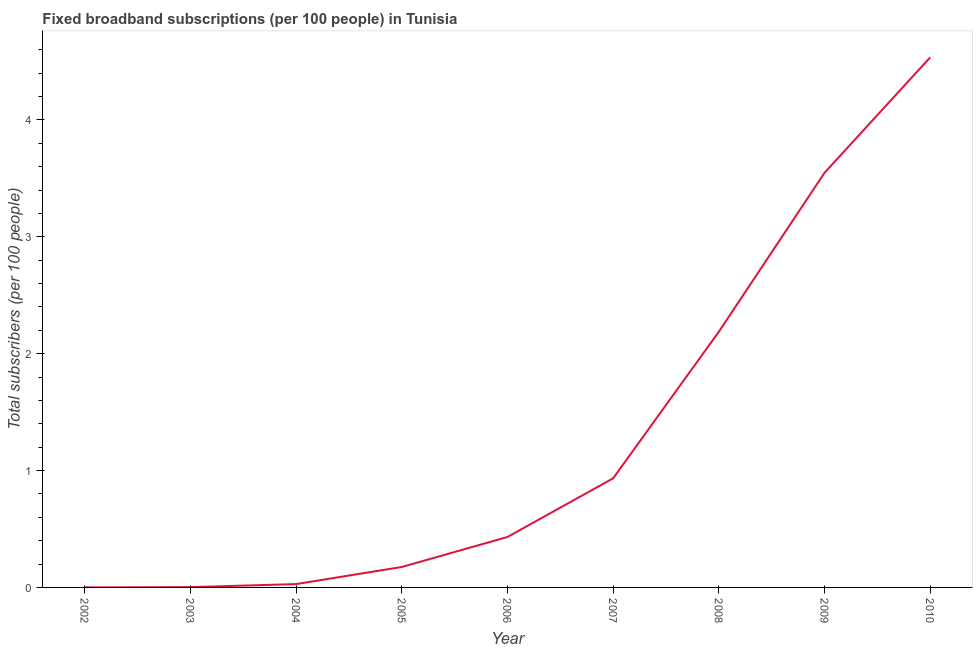What is the total number of fixed broadband subscriptions in 2009?
Offer a very short reply. 3.55. Across all years, what is the maximum total number of fixed broadband subscriptions?
Make the answer very short. 4.54. Across all years, what is the minimum total number of fixed broadband subscriptions?
Your answer should be very brief. 0. What is the sum of the total number of fixed broadband subscriptions?
Offer a terse response. 11.84. What is the difference between the total number of fixed broadband subscriptions in 2003 and 2009?
Your answer should be compact. -3.54. What is the average total number of fixed broadband subscriptions per year?
Make the answer very short. 1.32. What is the median total number of fixed broadband subscriptions?
Offer a very short reply. 0.43. Do a majority of the years between 2005 and 2002 (inclusive) have total number of fixed broadband subscriptions greater than 3.2 ?
Provide a succinct answer. Yes. What is the ratio of the total number of fixed broadband subscriptions in 2004 to that in 2010?
Keep it short and to the point. 0.01. Is the total number of fixed broadband subscriptions in 2002 less than that in 2005?
Keep it short and to the point. Yes. What is the difference between the highest and the second highest total number of fixed broadband subscriptions?
Ensure brevity in your answer.  0.99. What is the difference between the highest and the lowest total number of fixed broadband subscriptions?
Ensure brevity in your answer.  4.54. What is the difference between two consecutive major ticks on the Y-axis?
Provide a short and direct response. 1. Are the values on the major ticks of Y-axis written in scientific E-notation?
Provide a short and direct response. No. Does the graph contain grids?
Make the answer very short. No. What is the title of the graph?
Give a very brief answer. Fixed broadband subscriptions (per 100 people) in Tunisia. What is the label or title of the Y-axis?
Provide a short and direct response. Total subscribers (per 100 people). What is the Total subscribers (per 100 people) in 2002?
Give a very brief answer. 0. What is the Total subscribers (per 100 people) in 2003?
Provide a short and direct response. 0. What is the Total subscribers (per 100 people) in 2004?
Ensure brevity in your answer.  0.03. What is the Total subscribers (per 100 people) of 2005?
Make the answer very short. 0.17. What is the Total subscribers (per 100 people) of 2006?
Give a very brief answer. 0.43. What is the Total subscribers (per 100 people) of 2007?
Provide a succinct answer. 0.93. What is the Total subscribers (per 100 people) of 2008?
Give a very brief answer. 2.19. What is the Total subscribers (per 100 people) in 2009?
Your answer should be very brief. 3.55. What is the Total subscribers (per 100 people) in 2010?
Ensure brevity in your answer.  4.54. What is the difference between the Total subscribers (per 100 people) in 2002 and 2003?
Your answer should be compact. -0. What is the difference between the Total subscribers (per 100 people) in 2002 and 2004?
Your response must be concise. -0.03. What is the difference between the Total subscribers (per 100 people) in 2002 and 2005?
Offer a very short reply. -0.17. What is the difference between the Total subscribers (per 100 people) in 2002 and 2006?
Your response must be concise. -0.43. What is the difference between the Total subscribers (per 100 people) in 2002 and 2007?
Offer a terse response. -0.93. What is the difference between the Total subscribers (per 100 people) in 2002 and 2008?
Ensure brevity in your answer.  -2.19. What is the difference between the Total subscribers (per 100 people) in 2002 and 2009?
Make the answer very short. -3.55. What is the difference between the Total subscribers (per 100 people) in 2002 and 2010?
Ensure brevity in your answer.  -4.54. What is the difference between the Total subscribers (per 100 people) in 2003 and 2004?
Your response must be concise. -0.03. What is the difference between the Total subscribers (per 100 people) in 2003 and 2005?
Keep it short and to the point. -0.17. What is the difference between the Total subscribers (per 100 people) in 2003 and 2006?
Provide a short and direct response. -0.43. What is the difference between the Total subscribers (per 100 people) in 2003 and 2007?
Offer a very short reply. -0.93. What is the difference between the Total subscribers (per 100 people) in 2003 and 2008?
Provide a short and direct response. -2.19. What is the difference between the Total subscribers (per 100 people) in 2003 and 2009?
Provide a short and direct response. -3.54. What is the difference between the Total subscribers (per 100 people) in 2003 and 2010?
Provide a succinct answer. -4.53. What is the difference between the Total subscribers (per 100 people) in 2004 and 2005?
Your answer should be compact. -0.15. What is the difference between the Total subscribers (per 100 people) in 2004 and 2006?
Your answer should be compact. -0.4. What is the difference between the Total subscribers (per 100 people) in 2004 and 2007?
Make the answer very short. -0.91. What is the difference between the Total subscribers (per 100 people) in 2004 and 2008?
Provide a succinct answer. -2.16. What is the difference between the Total subscribers (per 100 people) in 2004 and 2009?
Your answer should be very brief. -3.52. What is the difference between the Total subscribers (per 100 people) in 2004 and 2010?
Keep it short and to the point. -4.51. What is the difference between the Total subscribers (per 100 people) in 2005 and 2006?
Your answer should be compact. -0.26. What is the difference between the Total subscribers (per 100 people) in 2005 and 2007?
Ensure brevity in your answer.  -0.76. What is the difference between the Total subscribers (per 100 people) in 2005 and 2008?
Offer a terse response. -2.01. What is the difference between the Total subscribers (per 100 people) in 2005 and 2009?
Your answer should be compact. -3.37. What is the difference between the Total subscribers (per 100 people) in 2005 and 2010?
Offer a very short reply. -4.36. What is the difference between the Total subscribers (per 100 people) in 2006 and 2007?
Give a very brief answer. -0.5. What is the difference between the Total subscribers (per 100 people) in 2006 and 2008?
Offer a very short reply. -1.76. What is the difference between the Total subscribers (per 100 people) in 2006 and 2009?
Make the answer very short. -3.12. What is the difference between the Total subscribers (per 100 people) in 2006 and 2010?
Your answer should be very brief. -4.1. What is the difference between the Total subscribers (per 100 people) in 2007 and 2008?
Ensure brevity in your answer.  -1.25. What is the difference between the Total subscribers (per 100 people) in 2007 and 2009?
Ensure brevity in your answer.  -2.61. What is the difference between the Total subscribers (per 100 people) in 2007 and 2010?
Ensure brevity in your answer.  -3.6. What is the difference between the Total subscribers (per 100 people) in 2008 and 2009?
Offer a terse response. -1.36. What is the difference between the Total subscribers (per 100 people) in 2008 and 2010?
Ensure brevity in your answer.  -2.35. What is the difference between the Total subscribers (per 100 people) in 2009 and 2010?
Your response must be concise. -0.99. What is the ratio of the Total subscribers (per 100 people) in 2002 to that in 2003?
Your answer should be compact. 0.1. What is the ratio of the Total subscribers (per 100 people) in 2002 to that in 2004?
Offer a very short reply. 0.01. What is the ratio of the Total subscribers (per 100 people) in 2002 to that in 2005?
Your answer should be very brief. 0. What is the ratio of the Total subscribers (per 100 people) in 2002 to that in 2006?
Your answer should be very brief. 0. What is the ratio of the Total subscribers (per 100 people) in 2002 to that in 2007?
Give a very brief answer. 0. What is the ratio of the Total subscribers (per 100 people) in 2002 to that in 2008?
Provide a succinct answer. 0. What is the ratio of the Total subscribers (per 100 people) in 2003 to that in 2004?
Your answer should be compact. 0.09. What is the ratio of the Total subscribers (per 100 people) in 2003 to that in 2005?
Provide a short and direct response. 0.01. What is the ratio of the Total subscribers (per 100 people) in 2003 to that in 2006?
Make the answer very short. 0.01. What is the ratio of the Total subscribers (per 100 people) in 2003 to that in 2007?
Keep it short and to the point. 0. What is the ratio of the Total subscribers (per 100 people) in 2003 to that in 2008?
Your answer should be very brief. 0. What is the ratio of the Total subscribers (per 100 people) in 2003 to that in 2010?
Your response must be concise. 0. What is the ratio of the Total subscribers (per 100 people) in 2004 to that in 2005?
Provide a short and direct response. 0.16. What is the ratio of the Total subscribers (per 100 people) in 2004 to that in 2006?
Keep it short and to the point. 0.07. What is the ratio of the Total subscribers (per 100 people) in 2004 to that in 2007?
Provide a succinct answer. 0.03. What is the ratio of the Total subscribers (per 100 people) in 2004 to that in 2008?
Provide a short and direct response. 0.01. What is the ratio of the Total subscribers (per 100 people) in 2004 to that in 2009?
Give a very brief answer. 0.01. What is the ratio of the Total subscribers (per 100 people) in 2004 to that in 2010?
Your answer should be very brief. 0.01. What is the ratio of the Total subscribers (per 100 people) in 2005 to that in 2006?
Offer a very short reply. 0.41. What is the ratio of the Total subscribers (per 100 people) in 2005 to that in 2007?
Provide a short and direct response. 0.19. What is the ratio of the Total subscribers (per 100 people) in 2005 to that in 2009?
Offer a terse response. 0.05. What is the ratio of the Total subscribers (per 100 people) in 2005 to that in 2010?
Give a very brief answer. 0.04. What is the ratio of the Total subscribers (per 100 people) in 2006 to that in 2007?
Give a very brief answer. 0.46. What is the ratio of the Total subscribers (per 100 people) in 2006 to that in 2008?
Keep it short and to the point. 0.2. What is the ratio of the Total subscribers (per 100 people) in 2006 to that in 2009?
Your answer should be compact. 0.12. What is the ratio of the Total subscribers (per 100 people) in 2006 to that in 2010?
Your answer should be very brief. 0.1. What is the ratio of the Total subscribers (per 100 people) in 2007 to that in 2008?
Provide a short and direct response. 0.43. What is the ratio of the Total subscribers (per 100 people) in 2007 to that in 2009?
Offer a terse response. 0.26. What is the ratio of the Total subscribers (per 100 people) in 2007 to that in 2010?
Provide a short and direct response. 0.21. What is the ratio of the Total subscribers (per 100 people) in 2008 to that in 2009?
Your response must be concise. 0.62. What is the ratio of the Total subscribers (per 100 people) in 2008 to that in 2010?
Your answer should be compact. 0.48. What is the ratio of the Total subscribers (per 100 people) in 2009 to that in 2010?
Offer a terse response. 0.78. 